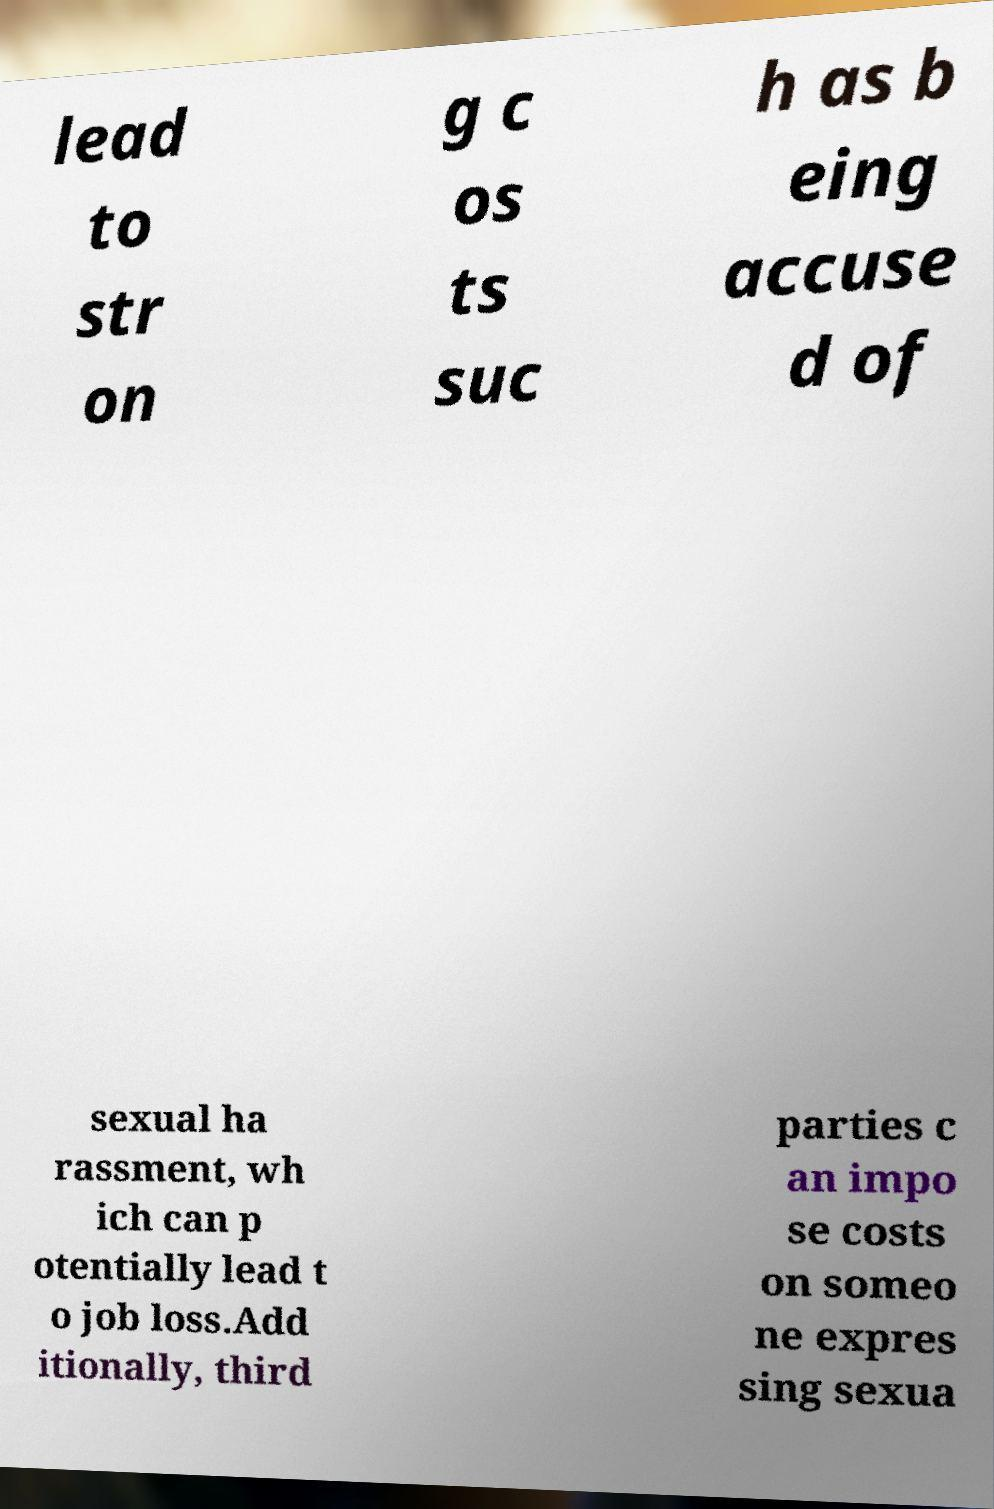Could you extract and type out the text from this image? lead to str on g c os ts suc h as b eing accuse d of sexual ha rassment, wh ich can p otentially lead t o job loss.Add itionally, third parties c an impo se costs on someo ne expres sing sexua 